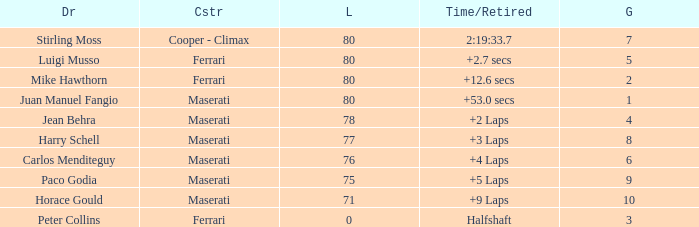Who was driving the Maserati with a Grid smaller than 6, and a Time/Retired of +2 laps? Jean Behra. 